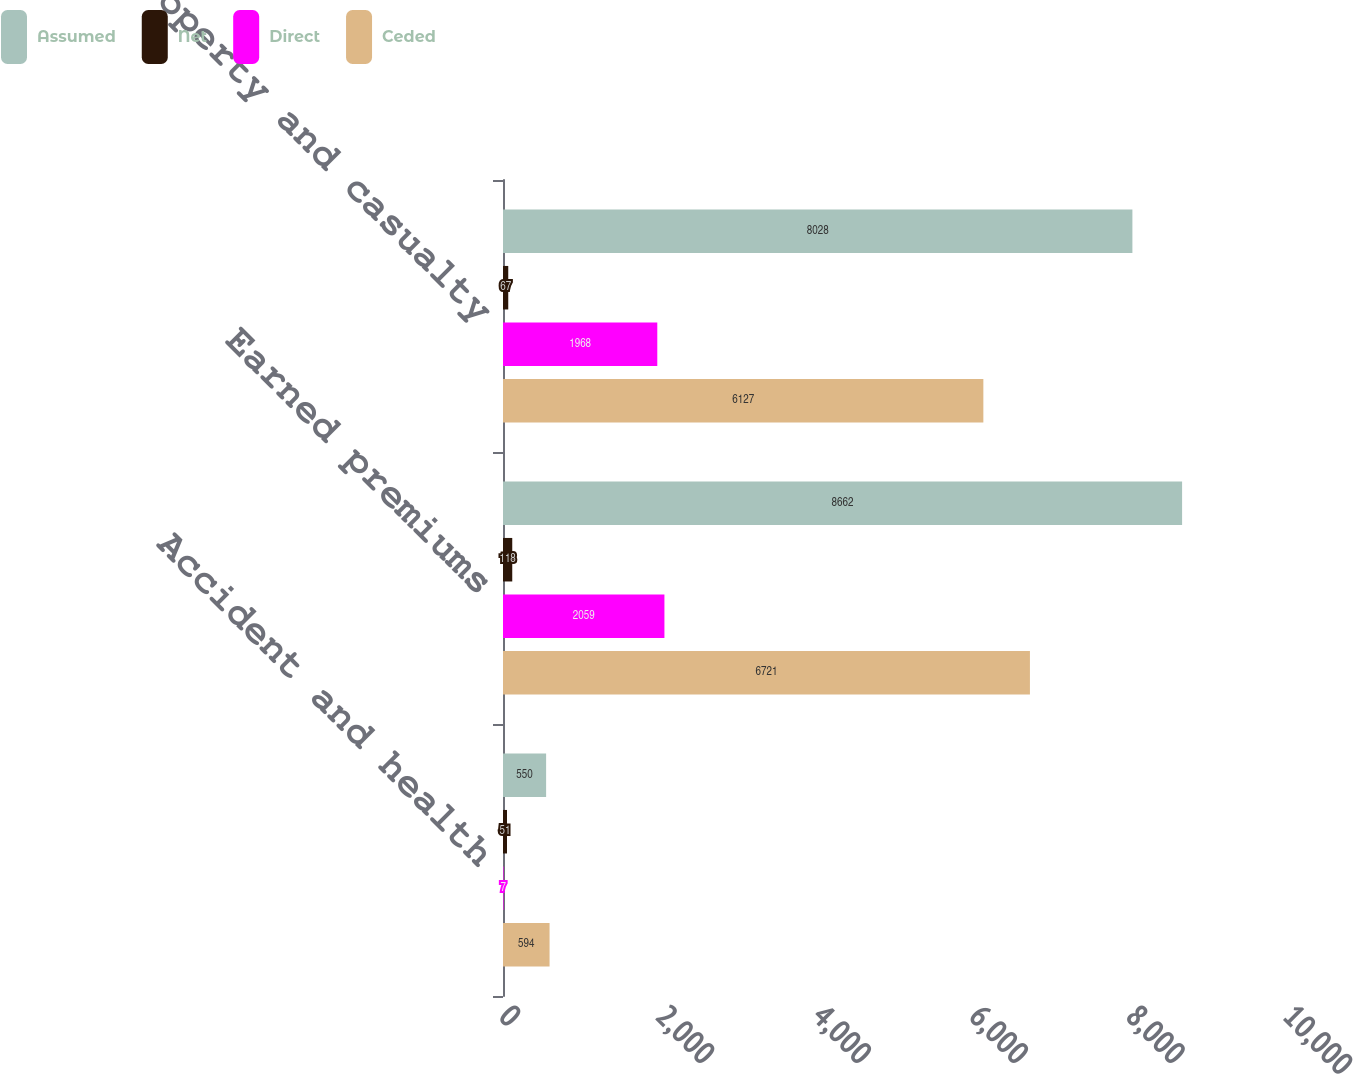<chart> <loc_0><loc_0><loc_500><loc_500><stacked_bar_chart><ecel><fcel>Accident and health<fcel>Earned premiums<fcel>Property and casualty<nl><fcel>Assumed<fcel>550<fcel>8662<fcel>8028<nl><fcel>Net<fcel>51<fcel>118<fcel>67<nl><fcel>Direct<fcel>7<fcel>2059<fcel>1968<nl><fcel>Ceded<fcel>594<fcel>6721<fcel>6127<nl></chart> 